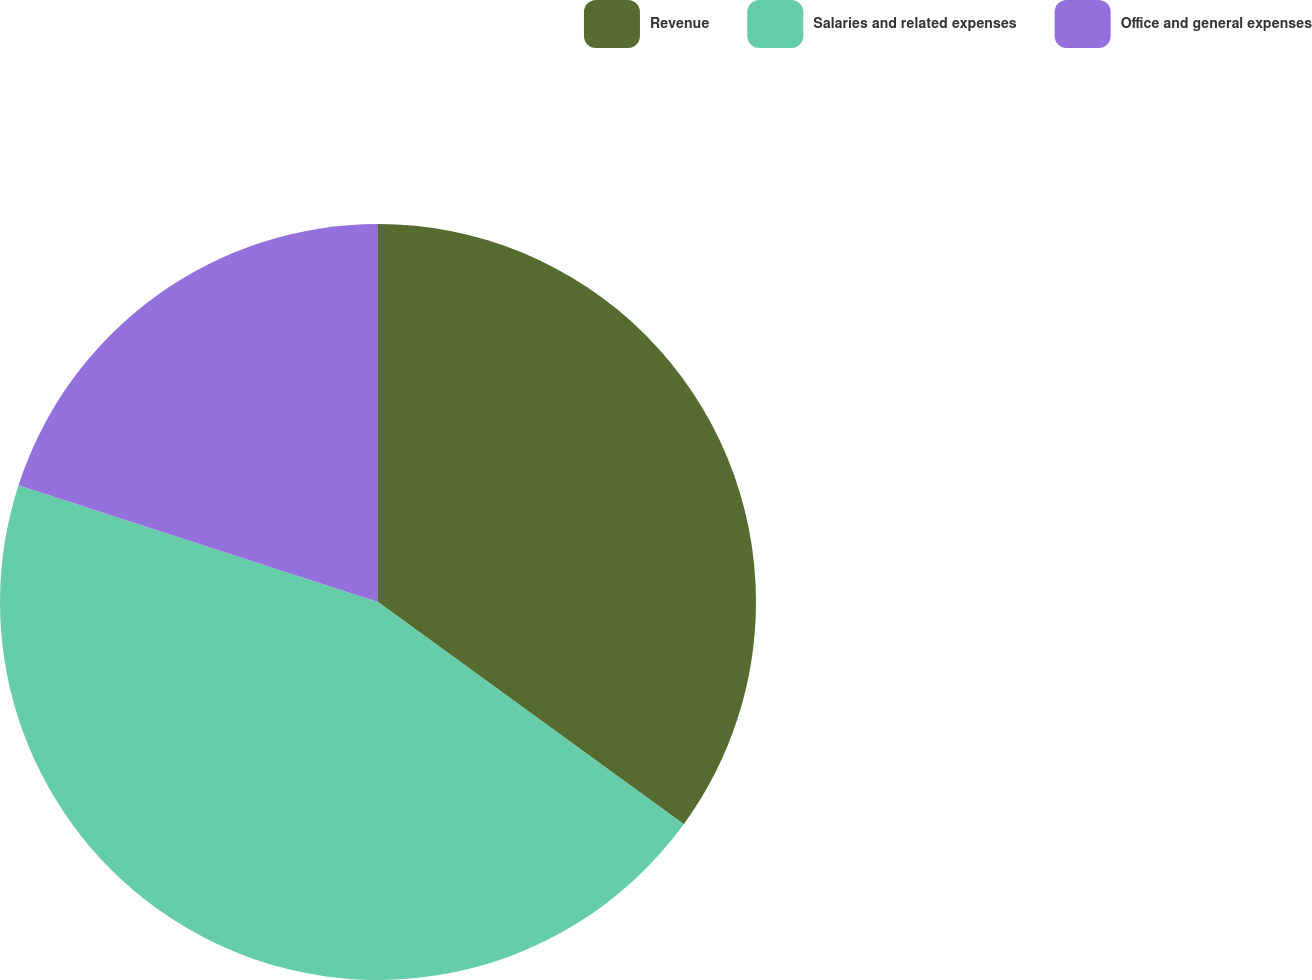Convert chart. <chart><loc_0><loc_0><loc_500><loc_500><pie_chart><fcel>Revenue<fcel>Salaries and related expenses<fcel>Office and general expenses<nl><fcel>35.0%<fcel>45.0%<fcel>20.0%<nl></chart> 